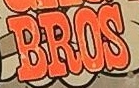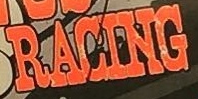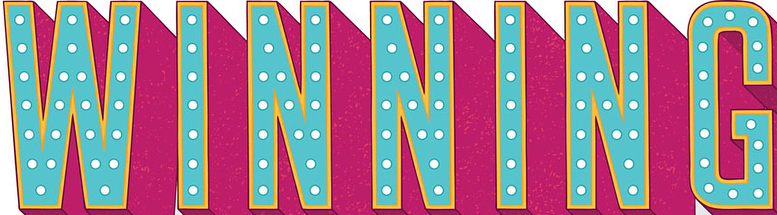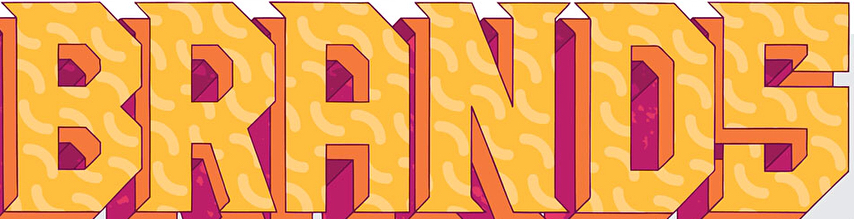What text appears in these images from left to right, separated by a semicolon? BROS; RACING; WINNING; BRANDS 